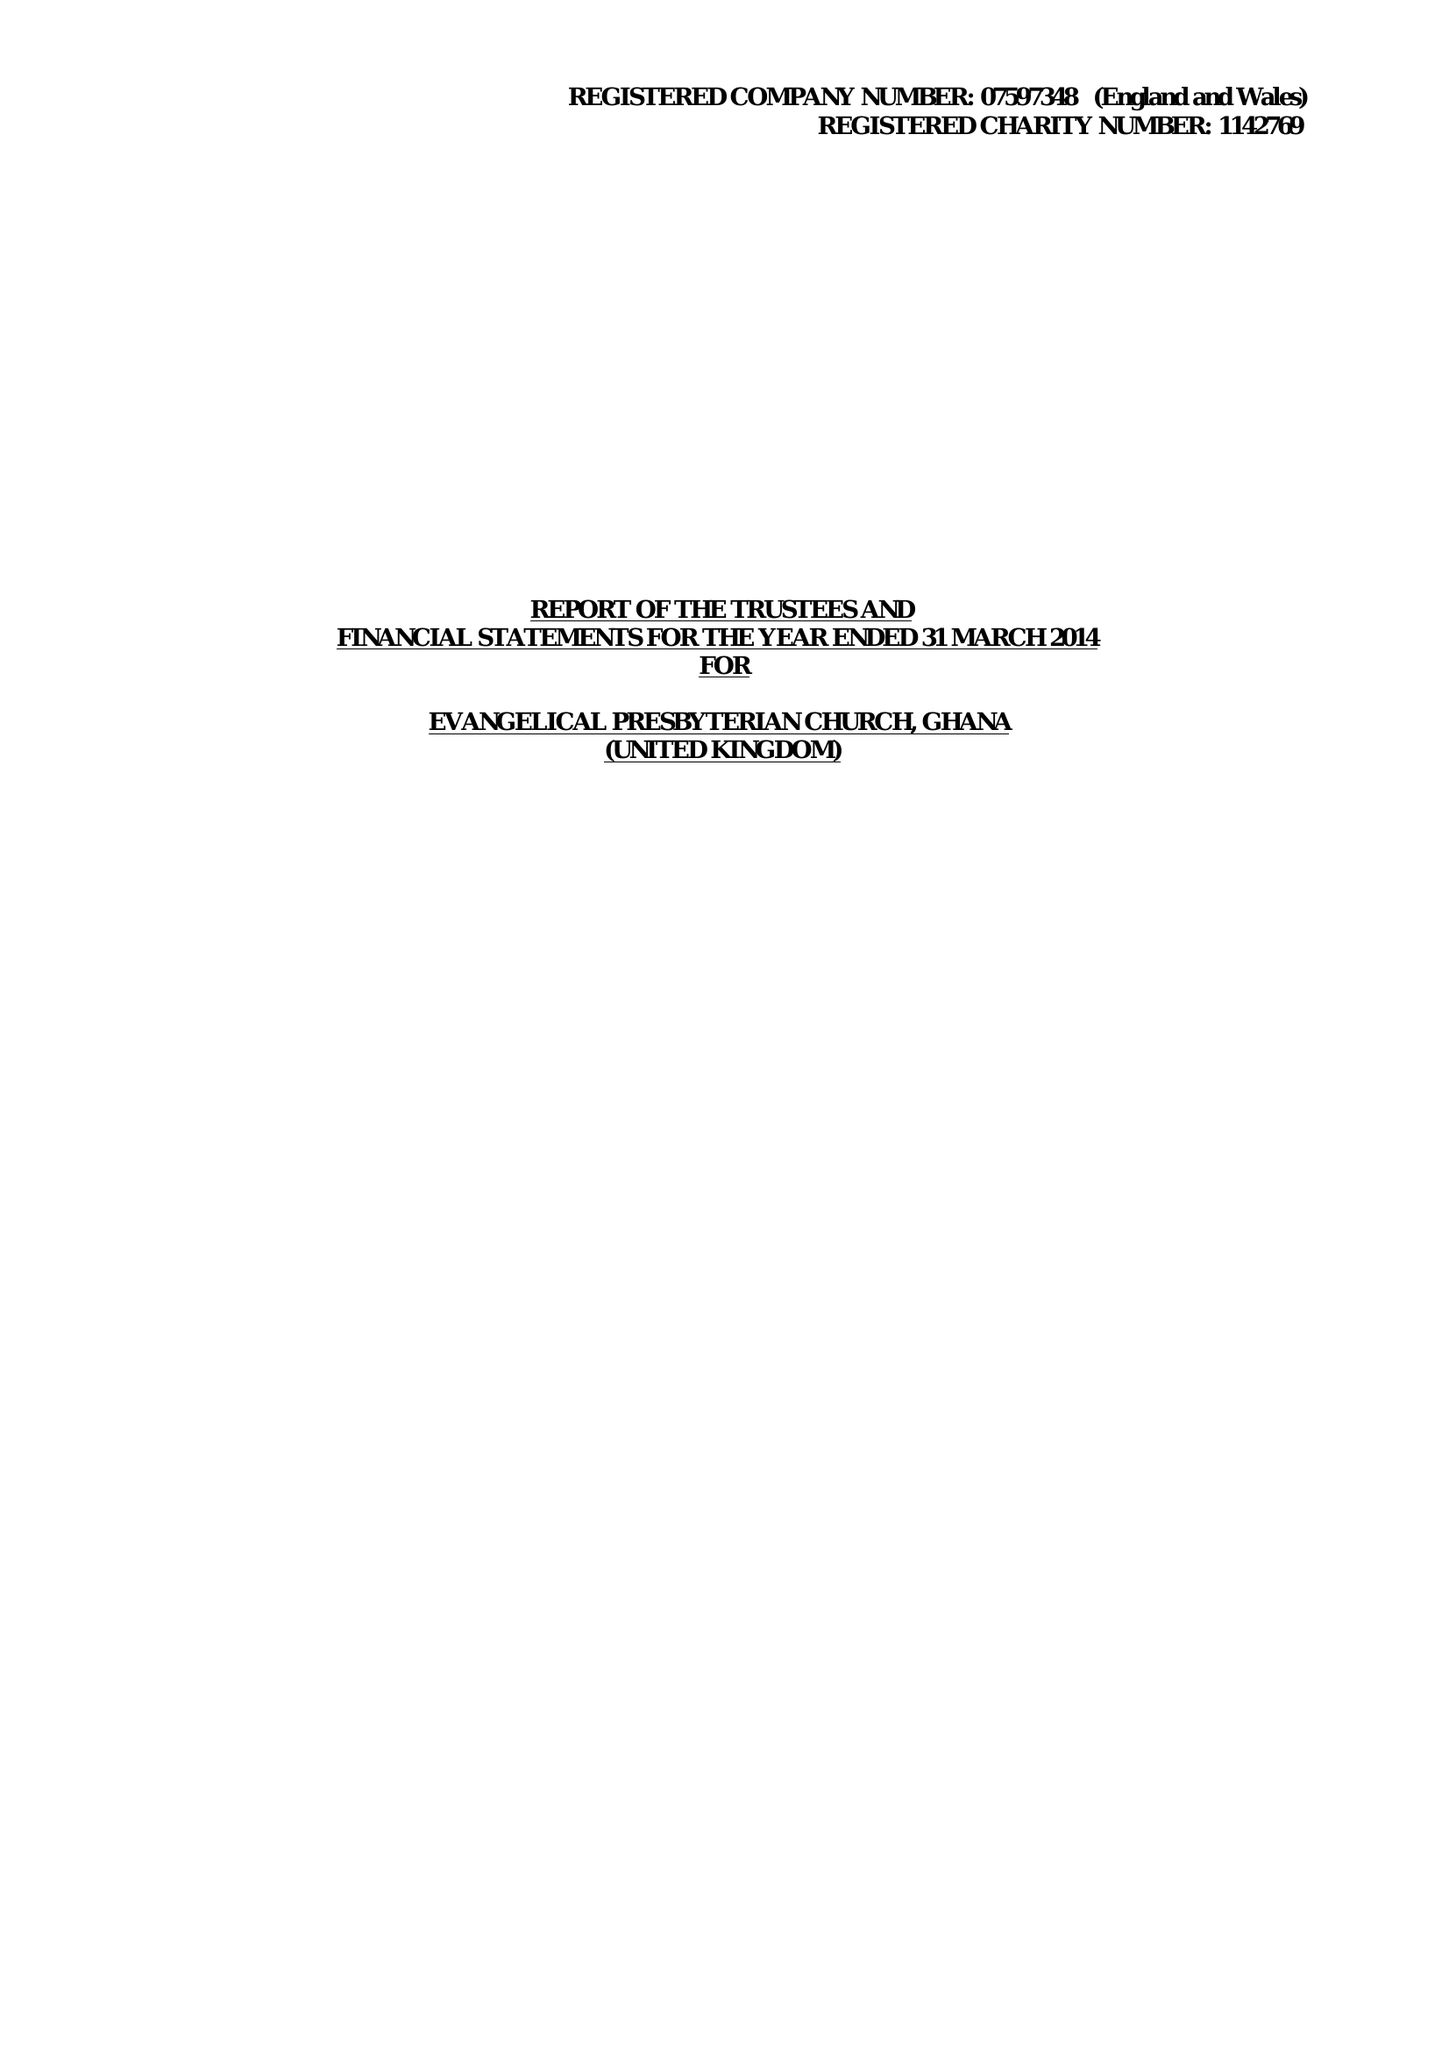What is the value for the address__postcode?
Answer the question using a single word or phrase. TW13 6YG 